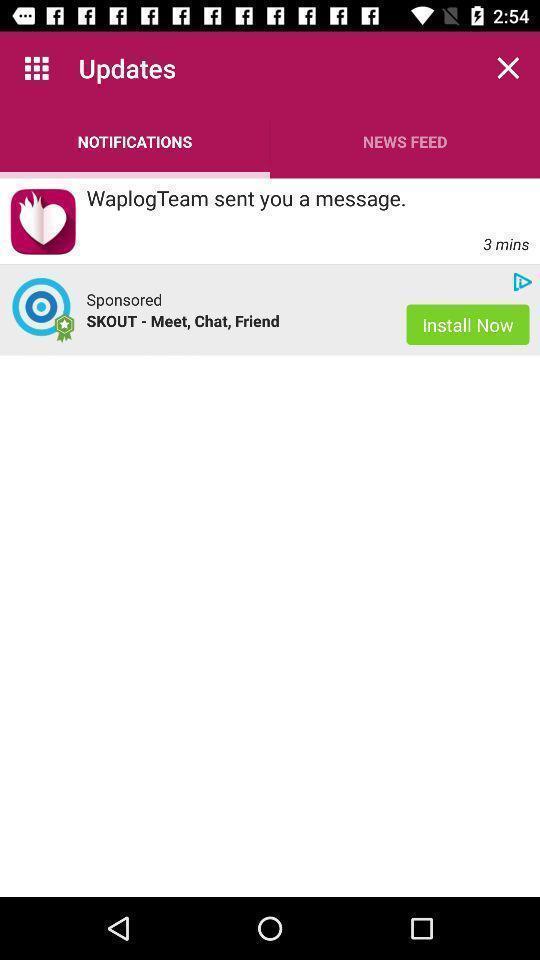Explain the elements present in this screenshot. Two different notifications in the mobile. 